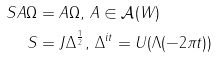Convert formula to latex. <formula><loc_0><loc_0><loc_500><loc_500>S A \Omega & = A \Omega , \, A \in \mathcal { A } ( W ) \\ S & = J \Delta ^ { \frac { 1 } { 2 } } , \, \Delta ^ { i t } = U ( \Lambda ( - 2 \pi t ) )</formula> 